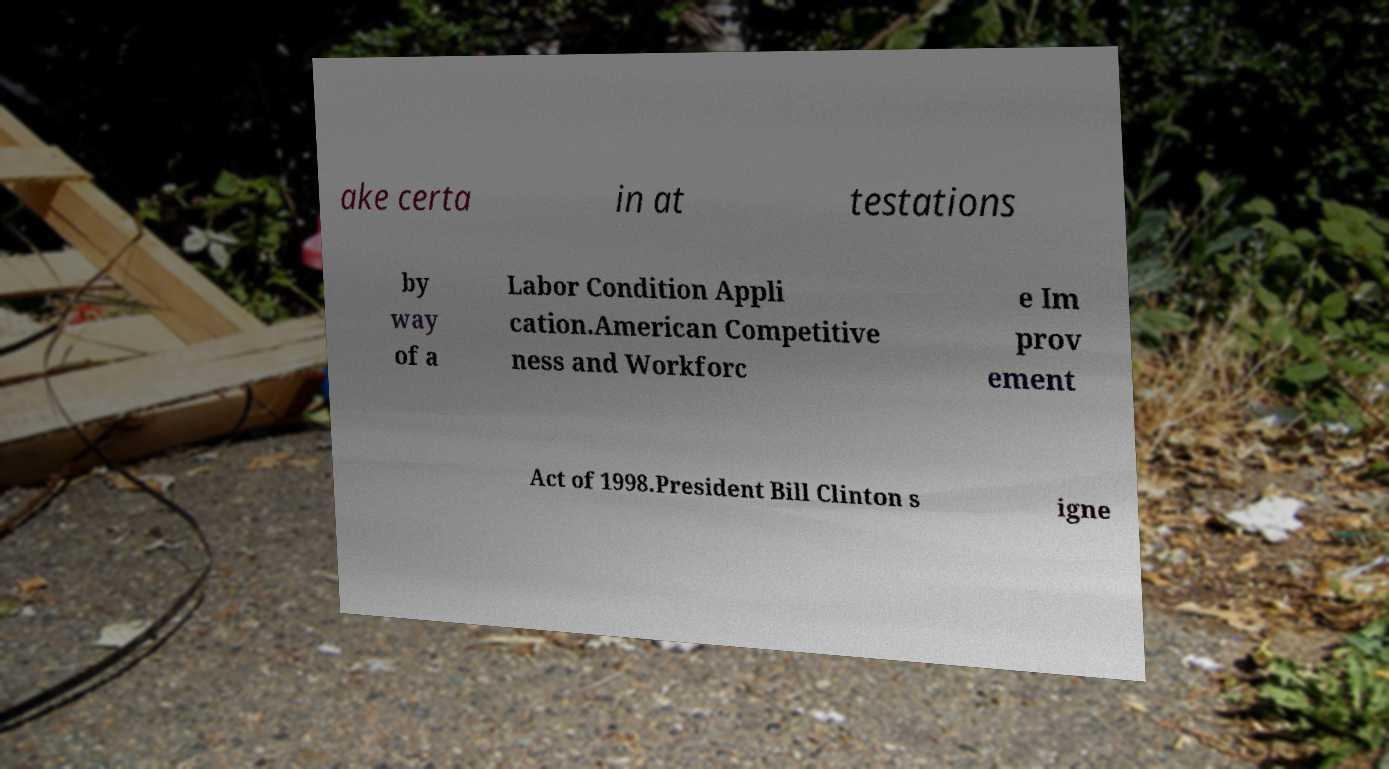There's text embedded in this image that I need extracted. Can you transcribe it verbatim? ake certa in at testations by way of a Labor Condition Appli cation.American Competitive ness and Workforc e Im prov ement Act of 1998.President Bill Clinton s igne 